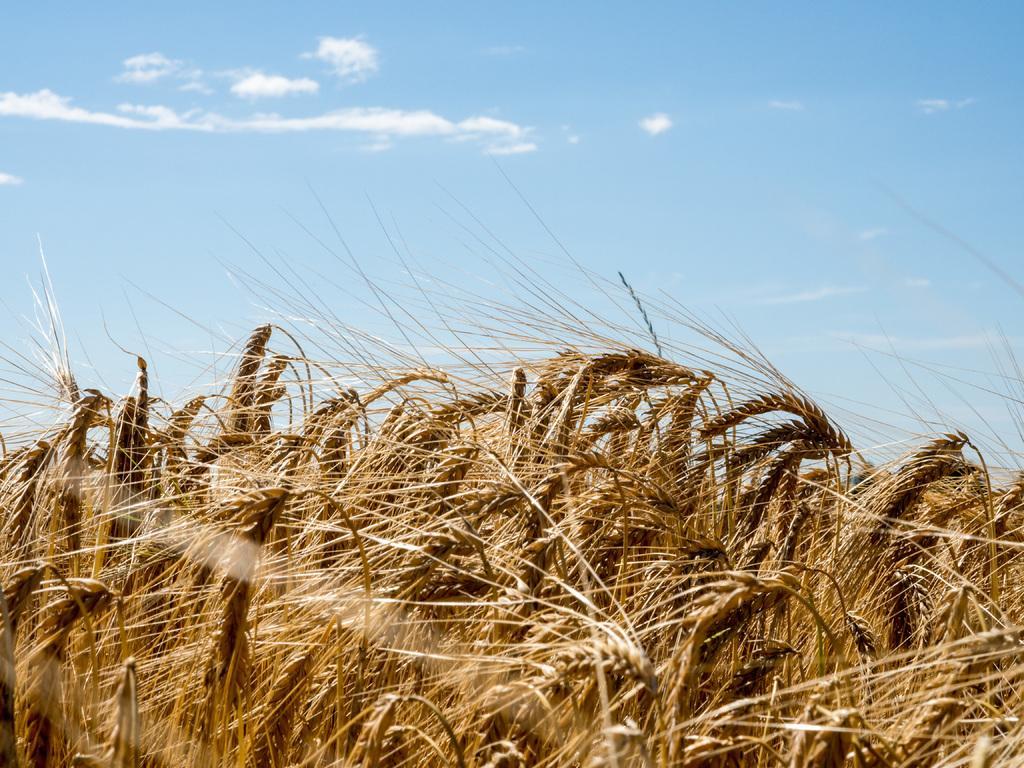In one or two sentences, can you explain what this image depicts? There are plants having seeds. In the background, there are clouds in the blue sky. 